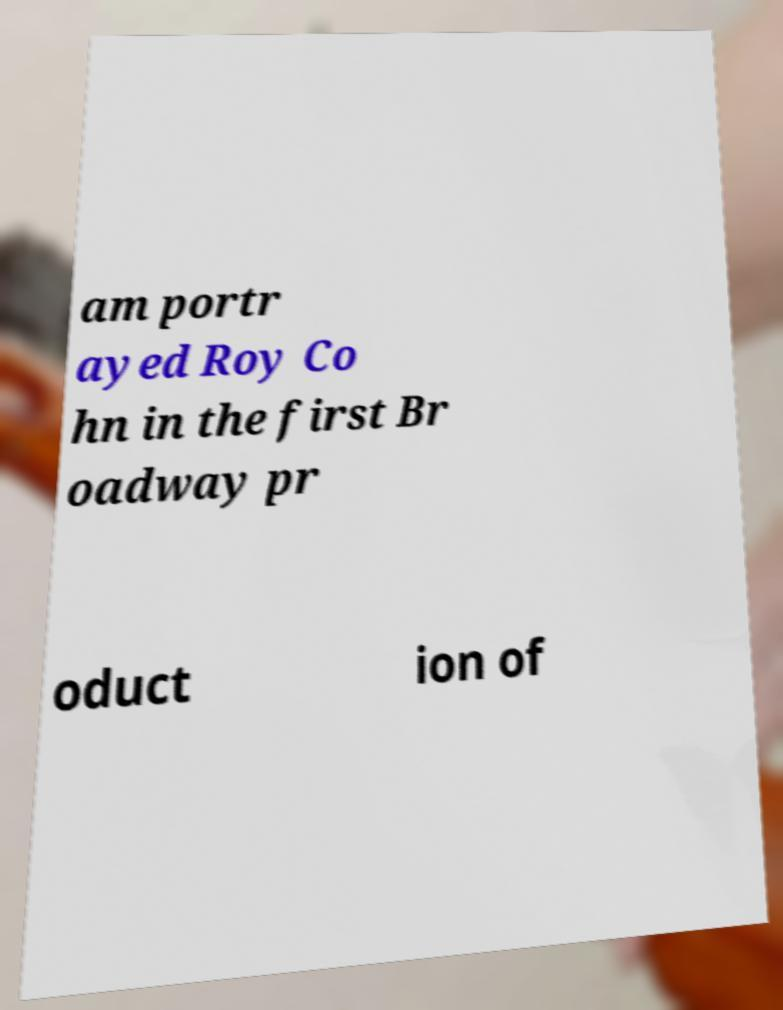For documentation purposes, I need the text within this image transcribed. Could you provide that? am portr ayed Roy Co hn in the first Br oadway pr oduct ion of 